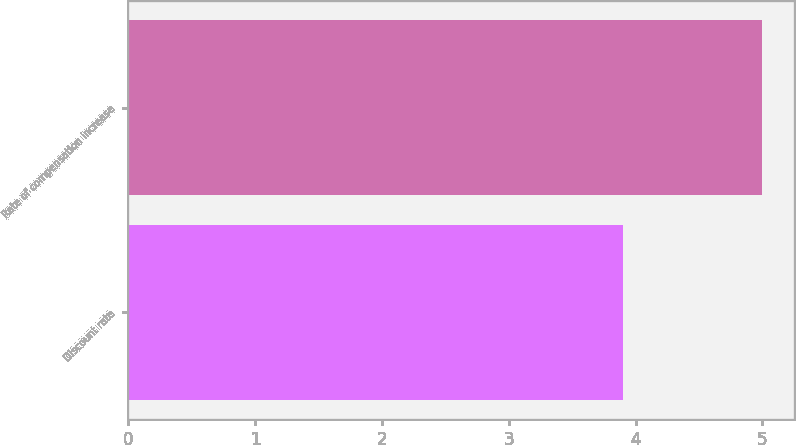Convert chart to OTSL. <chart><loc_0><loc_0><loc_500><loc_500><bar_chart><fcel>Discount rate<fcel>Rate of compensation increase<nl><fcel>3.9<fcel>5<nl></chart> 